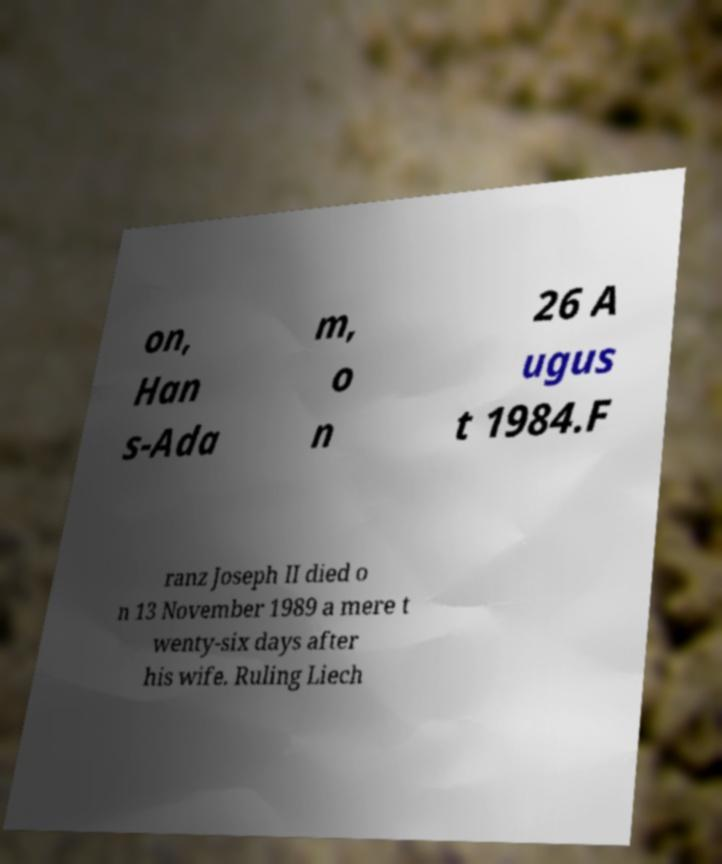There's text embedded in this image that I need extracted. Can you transcribe it verbatim? on, Han s-Ada m, o n 26 A ugus t 1984.F ranz Joseph II died o n 13 November 1989 a mere t wenty-six days after his wife. Ruling Liech 